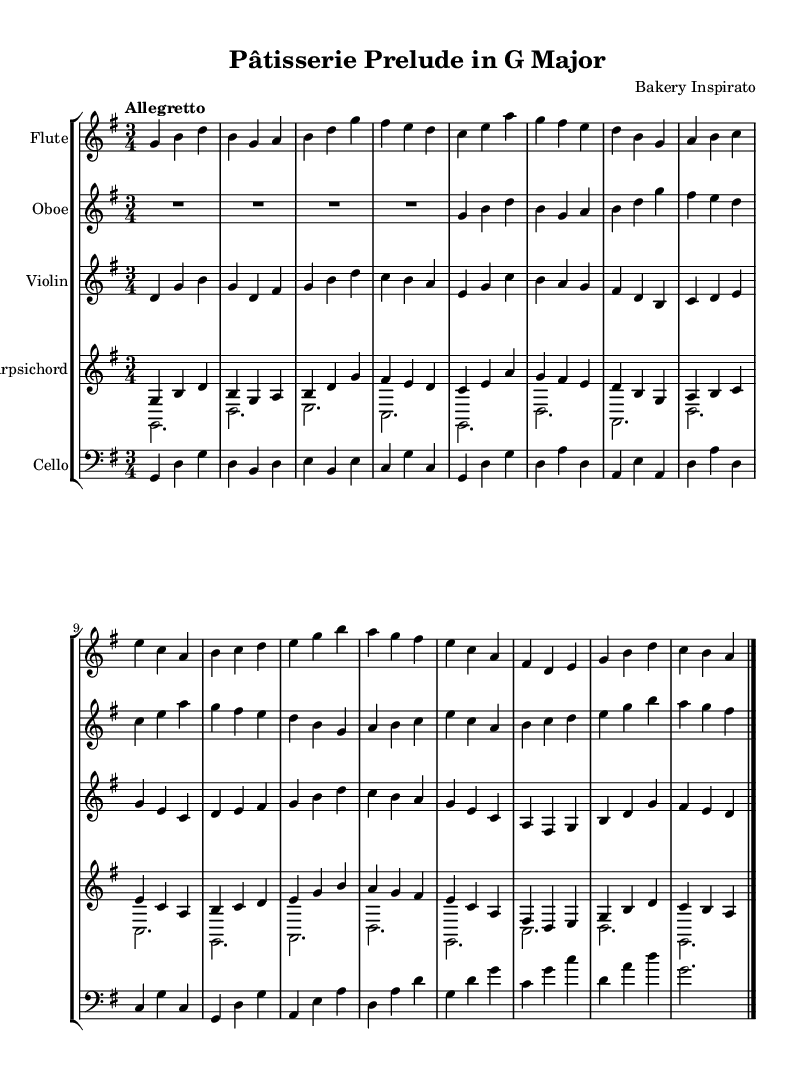What is the key signature of this music? The key signature is G major, which has one sharp (F#). This can be determined by looking at the key signature indicated at the beginning of the sheet music before the time signature.
Answer: G major What is the time signature of this music? The time signature is 3/4, indicated at the beginning of the sheet music. This means there are three beats in each measure, and the quarter note gets one beat.
Answer: 3/4 What is the tempo marking for this piece? The tempo marking is "Allegretto," which suggests a moderately fast tempo. This is noted at the beginning of the sheet music following the time signature.
Answer: Allegretto How many instruments are used in this composition? There are five instruments in this composition: Flute, Oboe, Violin, Harpsichord, and Cello. This can be concluded by counting the separate staves designated for each instrument in the score.
Answer: Five Which instrument has the highest pitch in this arrangement? The Flute typically has the highest pitch in orchestral and chamber settings. By examining the written notes for each instrument, the Flute consistently plays notes in the higher register compared to the others.
Answer: Flute What is the structure of the piece based on the measure layouts? The piece is structured in a repeating pattern of measures, with phrases that often echo each other and incorporate variations. The layout includes phrases for different instruments that are aligned in a way that showcases a conversation between them, a common Baroque characteristic.
Answer: Repeating phrases 